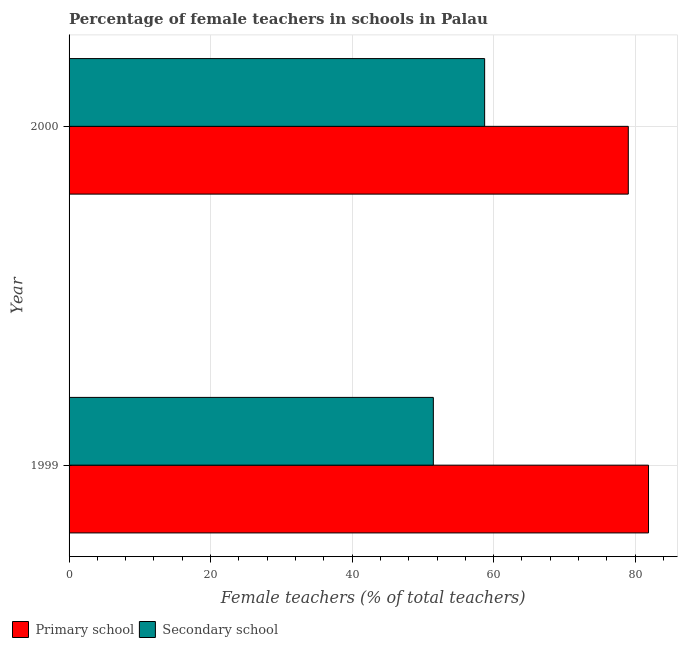How many different coloured bars are there?
Your answer should be very brief. 2. Are the number of bars on each tick of the Y-axis equal?
Your answer should be compact. Yes. In how many cases, is the number of bars for a given year not equal to the number of legend labels?
Give a very brief answer. 0. What is the percentage of female teachers in secondary schools in 2000?
Provide a short and direct response. 58.73. Across all years, what is the maximum percentage of female teachers in secondary schools?
Offer a very short reply. 58.73. Across all years, what is the minimum percentage of female teachers in primary schools?
Provide a short and direct response. 79.03. What is the total percentage of female teachers in primary schools in the graph?
Provide a succinct answer. 160.92. What is the difference between the percentage of female teachers in secondary schools in 1999 and that in 2000?
Provide a succinct answer. -7.25. What is the difference between the percentage of female teachers in secondary schools in 2000 and the percentage of female teachers in primary schools in 1999?
Your response must be concise. -23.16. What is the average percentage of female teachers in primary schools per year?
Make the answer very short. 80.46. In the year 1999, what is the difference between the percentage of female teachers in secondary schools and percentage of female teachers in primary schools?
Provide a short and direct response. -30.41. In how many years, is the percentage of female teachers in primary schools greater than 52 %?
Provide a short and direct response. 2. What is the ratio of the percentage of female teachers in secondary schools in 1999 to that in 2000?
Offer a terse response. 0.88. Is the percentage of female teachers in primary schools in 1999 less than that in 2000?
Make the answer very short. No. Is the difference between the percentage of female teachers in secondary schools in 1999 and 2000 greater than the difference between the percentage of female teachers in primary schools in 1999 and 2000?
Keep it short and to the point. No. What does the 2nd bar from the top in 2000 represents?
Keep it short and to the point. Primary school. What does the 2nd bar from the bottom in 1999 represents?
Offer a very short reply. Secondary school. What is the difference between two consecutive major ticks on the X-axis?
Provide a short and direct response. 20. Are the values on the major ticks of X-axis written in scientific E-notation?
Provide a succinct answer. No. Does the graph contain any zero values?
Offer a very short reply. No. How many legend labels are there?
Your answer should be very brief. 2. What is the title of the graph?
Your answer should be very brief. Percentage of female teachers in schools in Palau. Does "Lowest 20% of population" appear as one of the legend labels in the graph?
Keep it short and to the point. No. What is the label or title of the X-axis?
Keep it short and to the point. Female teachers (% of total teachers). What is the label or title of the Y-axis?
Your answer should be very brief. Year. What is the Female teachers (% of total teachers) in Primary school in 1999?
Offer a very short reply. 81.89. What is the Female teachers (% of total teachers) in Secondary school in 1999?
Your response must be concise. 51.48. What is the Female teachers (% of total teachers) of Primary school in 2000?
Provide a succinct answer. 79.03. What is the Female teachers (% of total teachers) in Secondary school in 2000?
Make the answer very short. 58.73. Across all years, what is the maximum Female teachers (% of total teachers) of Primary school?
Your response must be concise. 81.89. Across all years, what is the maximum Female teachers (% of total teachers) in Secondary school?
Your answer should be compact. 58.73. Across all years, what is the minimum Female teachers (% of total teachers) in Primary school?
Provide a short and direct response. 79.03. Across all years, what is the minimum Female teachers (% of total teachers) in Secondary school?
Give a very brief answer. 51.48. What is the total Female teachers (% of total teachers) in Primary school in the graph?
Give a very brief answer. 160.92. What is the total Female teachers (% of total teachers) of Secondary school in the graph?
Give a very brief answer. 110.21. What is the difference between the Female teachers (% of total teachers) of Primary school in 1999 and that in 2000?
Give a very brief answer. 2.86. What is the difference between the Female teachers (% of total teachers) of Secondary school in 1999 and that in 2000?
Your response must be concise. -7.25. What is the difference between the Female teachers (% of total teachers) of Primary school in 1999 and the Female teachers (% of total teachers) of Secondary school in 2000?
Your answer should be very brief. 23.16. What is the average Female teachers (% of total teachers) in Primary school per year?
Offer a very short reply. 80.46. What is the average Female teachers (% of total teachers) of Secondary school per year?
Provide a succinct answer. 55.1. In the year 1999, what is the difference between the Female teachers (% of total teachers) in Primary school and Female teachers (% of total teachers) in Secondary school?
Keep it short and to the point. 30.41. In the year 2000, what is the difference between the Female teachers (% of total teachers) in Primary school and Female teachers (% of total teachers) in Secondary school?
Your answer should be compact. 20.3. What is the ratio of the Female teachers (% of total teachers) in Primary school in 1999 to that in 2000?
Your response must be concise. 1.04. What is the ratio of the Female teachers (% of total teachers) of Secondary school in 1999 to that in 2000?
Your response must be concise. 0.88. What is the difference between the highest and the second highest Female teachers (% of total teachers) in Primary school?
Provide a succinct answer. 2.86. What is the difference between the highest and the second highest Female teachers (% of total teachers) of Secondary school?
Provide a succinct answer. 7.25. What is the difference between the highest and the lowest Female teachers (% of total teachers) in Primary school?
Keep it short and to the point. 2.86. What is the difference between the highest and the lowest Female teachers (% of total teachers) of Secondary school?
Keep it short and to the point. 7.25. 